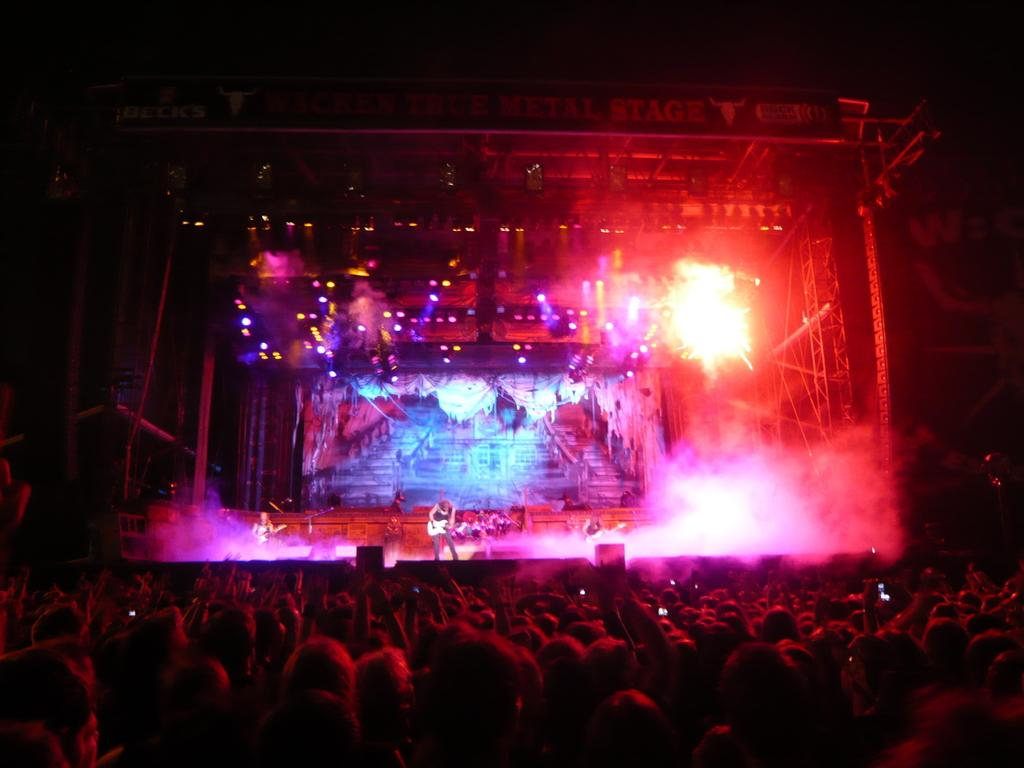What is happening in the image? There is a group of people in the image, and a person is playing a guitar on stage. Where is the person playing the guitar in relation to the group of people? The person playing the guitar is in front of the group of people. What can be seen in the background of the image? There are lights visible in the background of the image. What type of bead is being used to create the view in the image? There is no bead present in the image, and the view is not created by a bead. How does the toothpaste contribute to the performance in the image? There is no toothpaste present in the image, and it does not contribute to the performance. 